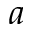<formula> <loc_0><loc_0><loc_500><loc_500>a</formula> 